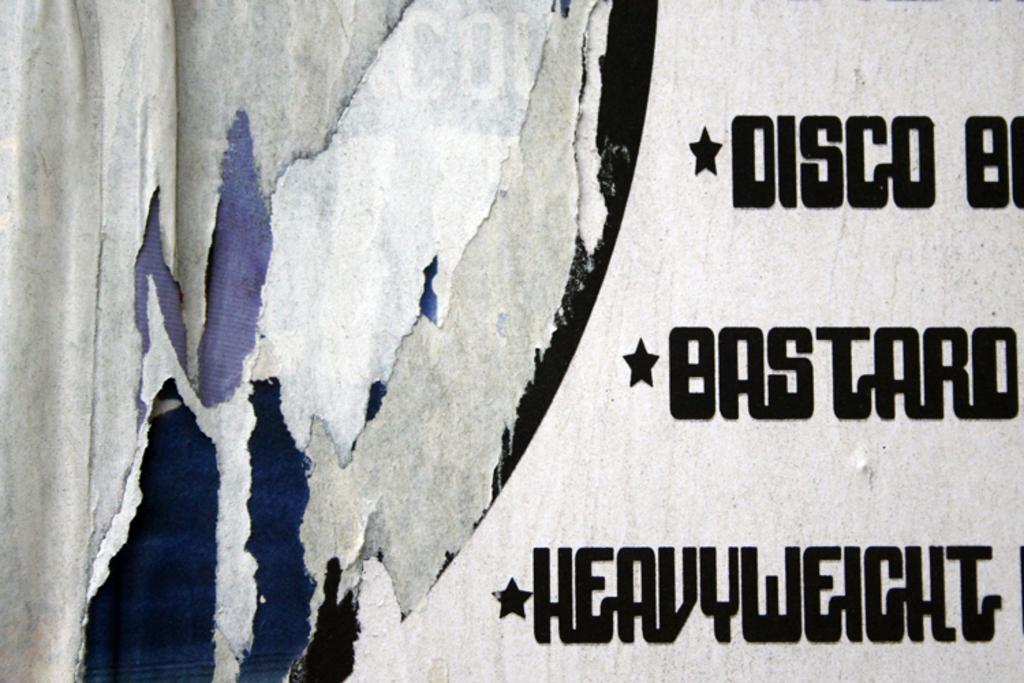What weight class is mentioned on the sign?
Make the answer very short. Heavyweight. What is the word next to the first star on the sign?
Offer a very short reply. Disco. 